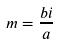<formula> <loc_0><loc_0><loc_500><loc_500>m = \frac { b i } { a }</formula> 